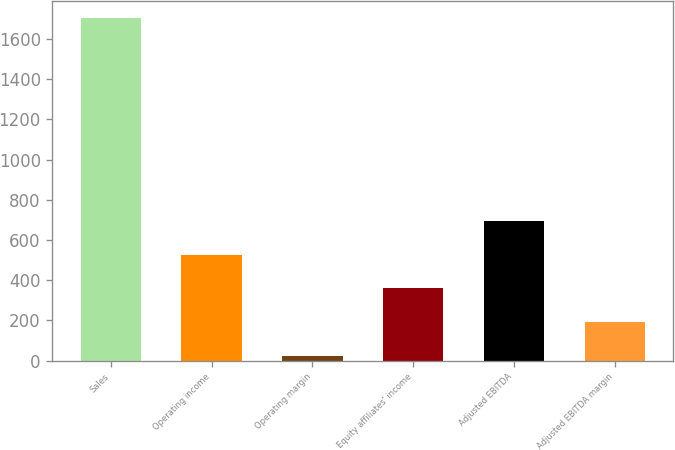<chart> <loc_0><loc_0><loc_500><loc_500><bar_chart><fcel>Sales<fcel>Operating income<fcel>Operating margin<fcel>Equity affiliates' income<fcel>Adjusted EBITDA<fcel>Adjusted EBITDA margin<nl><fcel>1704.4<fcel>527.14<fcel>22.6<fcel>358.96<fcel>695.32<fcel>190.78<nl></chart> 